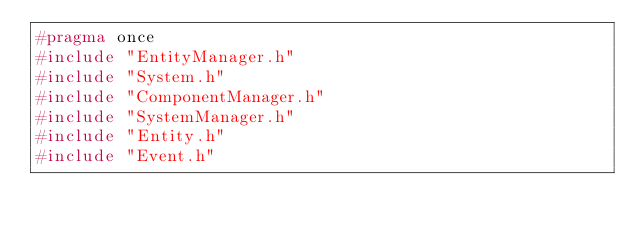Convert code to text. <code><loc_0><loc_0><loc_500><loc_500><_C_>#pragma once
#include "EntityManager.h"
#include "System.h"
#include "ComponentManager.h"
#include "SystemManager.h"
#include "Entity.h"
#include "Event.h"</code> 